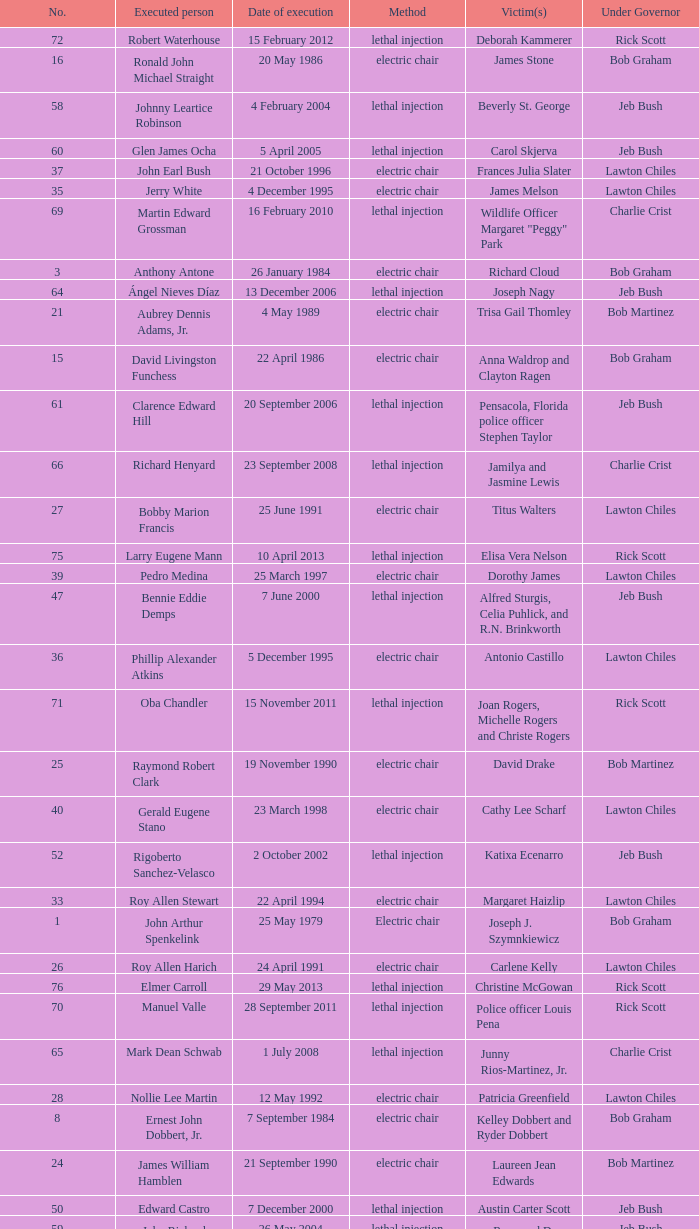What's the name of Linroy Bottoson's victim? Catherine Alexander. 